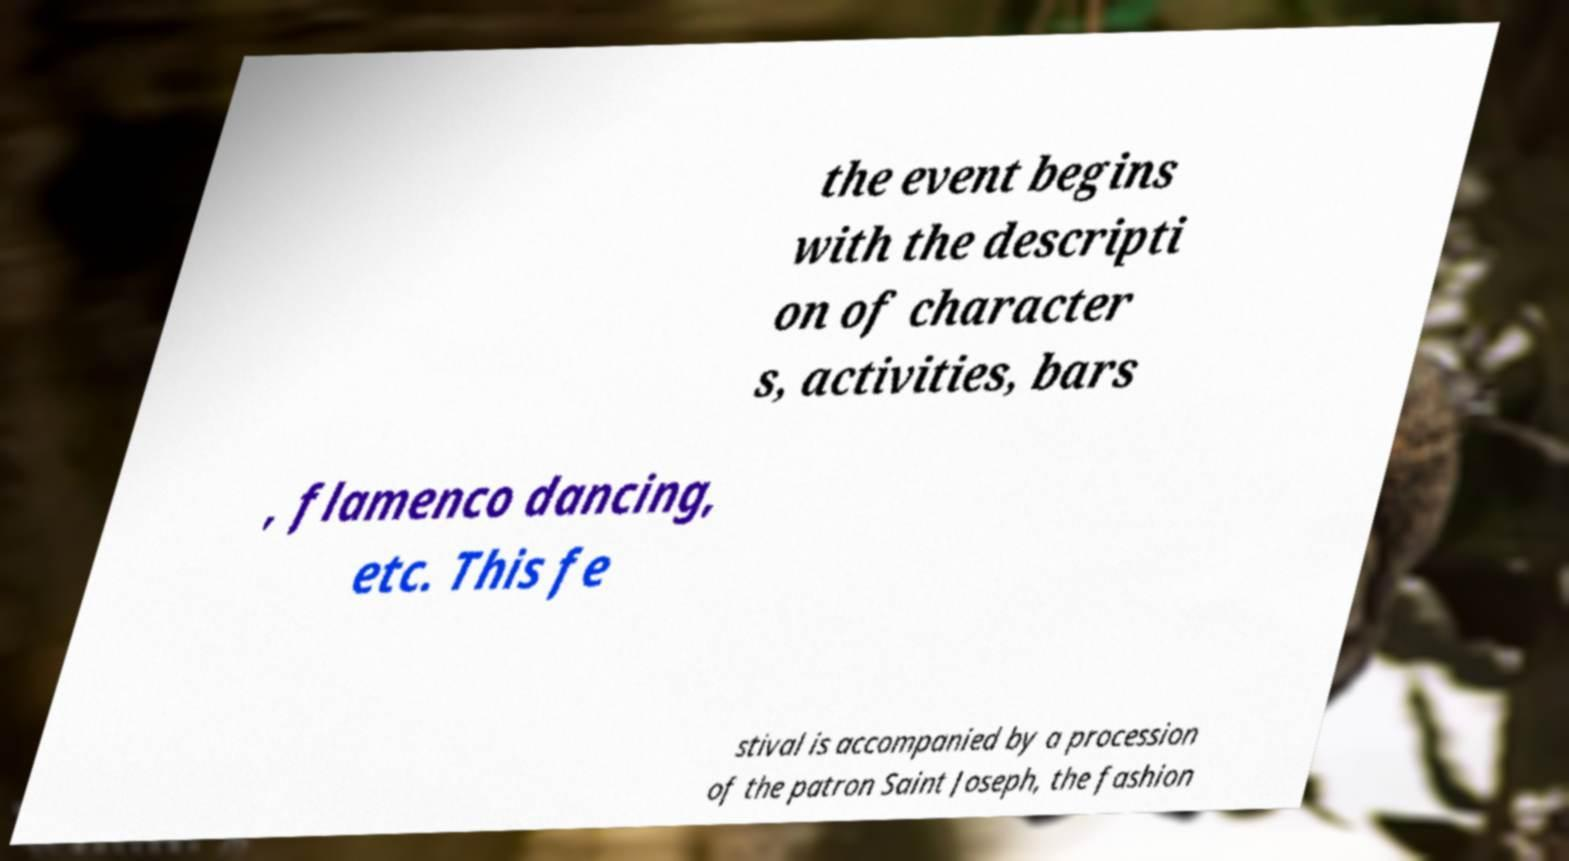I need the written content from this picture converted into text. Can you do that? the event begins with the descripti on of character s, activities, bars , flamenco dancing, etc. This fe stival is accompanied by a procession of the patron Saint Joseph, the fashion 